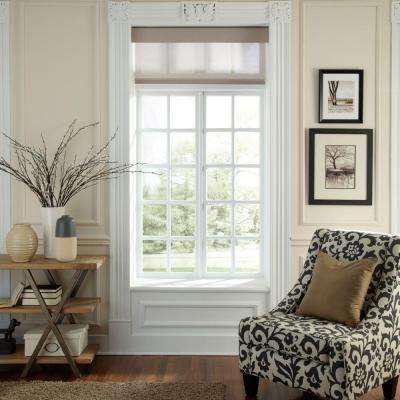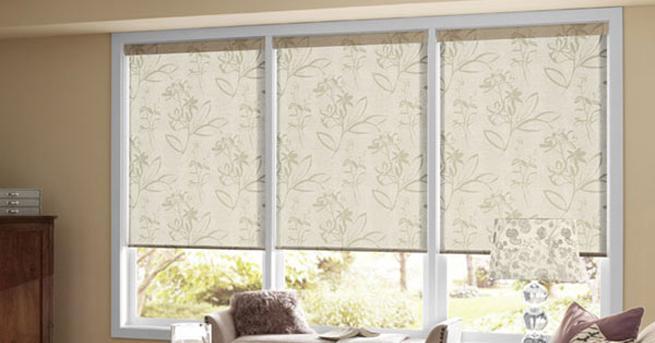The first image is the image on the left, the second image is the image on the right. Evaluate the accuracy of this statement regarding the images: "There is one solid blue chair/couch visible.". Is it true? Answer yes or no. No. The first image is the image on the left, the second image is the image on the right. Given the left and right images, does the statement "The left image shows one shade with a straight bottom hanging in front of, but not fully covering, a white paned window." hold true? Answer yes or no. Yes. 